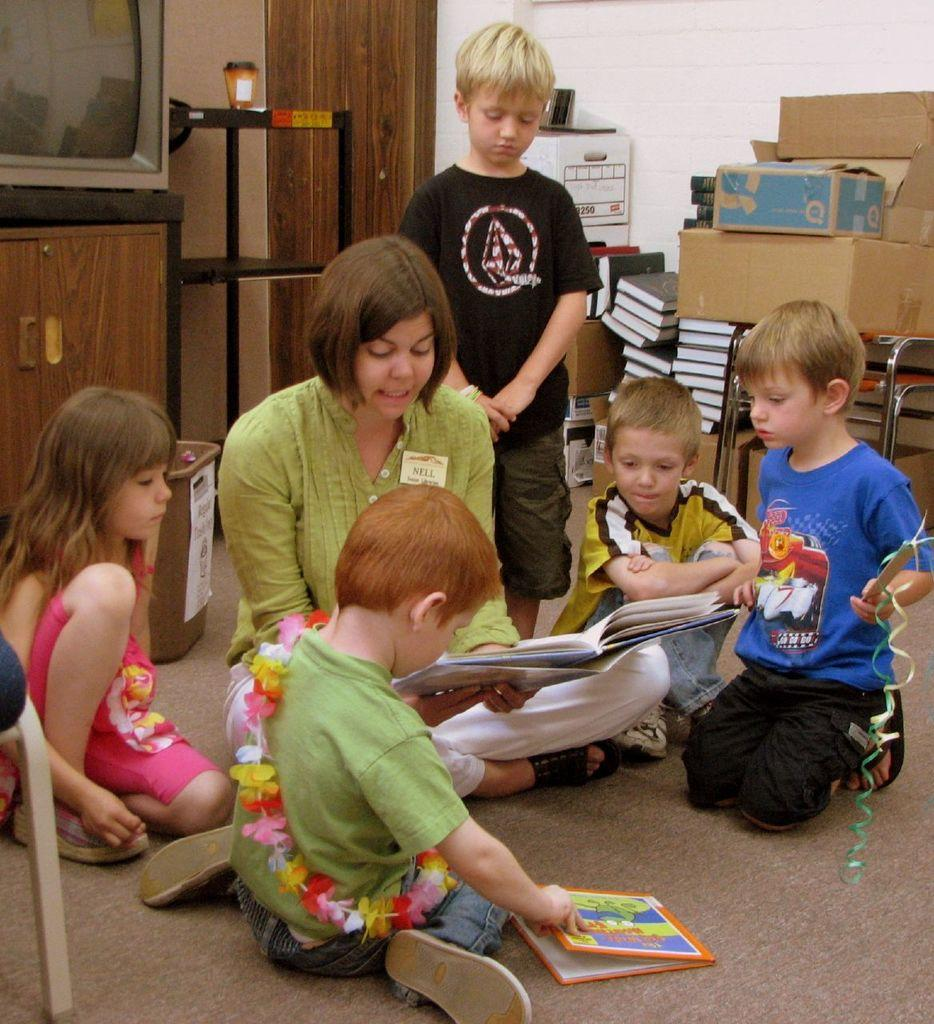How many people are on the floor in the image? There are six persons on the floor in the image. What objects can be seen in the background? In the background, there is a table, a TV, a lamp, books, cartoon boxes, a wall, and a chair. What type of room is the image taken in? The image is taken in a hall. What is the plot of the TV show being watched by the persons in the image? The image does not provide any information about the TV show being watched, so it is impossible to determine the plot. How does the digestion process of the persons on the floor affect the image? The digestion process of the persons on the floor is not visible or relevant in the image, so it does not affect the image. 